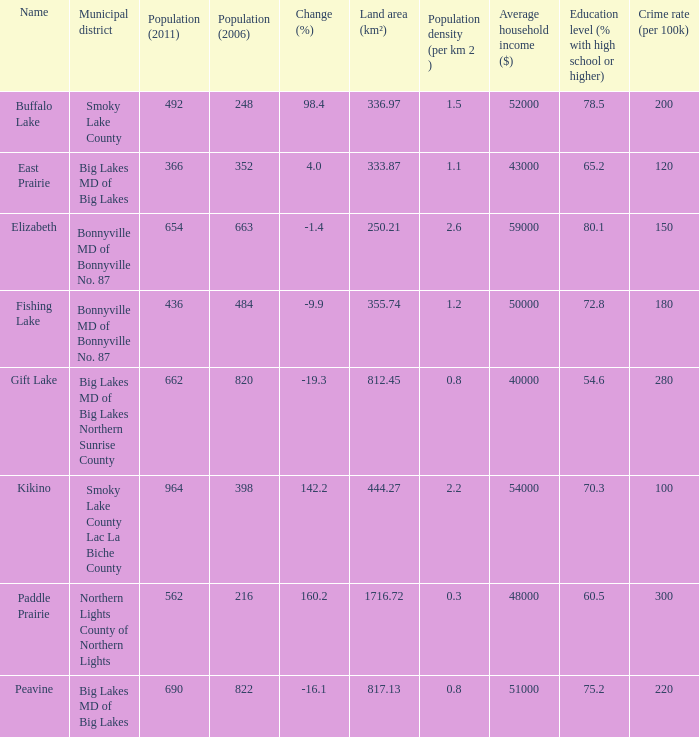What place is there a change of -19.3? 1.0. 